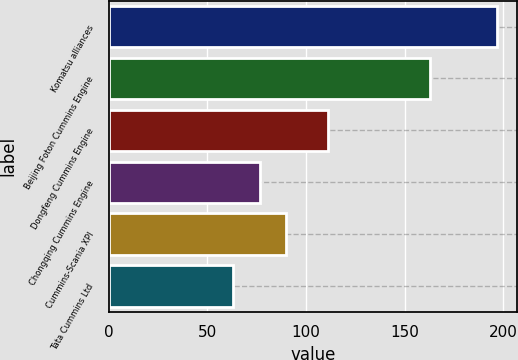Convert chart to OTSL. <chart><loc_0><loc_0><loc_500><loc_500><bar_chart><fcel>Komatsu alliances<fcel>Beijing Foton Cummins Engine<fcel>Dongfeng Cummins Engine<fcel>Chongqing Cummins Engine<fcel>Cummins-Scania XPI<fcel>Tata Cummins Ltd<nl><fcel>197<fcel>163<fcel>111<fcel>76.4<fcel>89.8<fcel>63<nl></chart> 